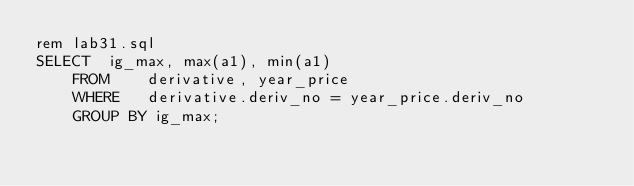<code> <loc_0><loc_0><loc_500><loc_500><_SQL_>rem lab31.sql
SELECT  ig_max, max(a1), min(a1)
	FROM	derivative, year_price
	WHERE 	derivative.deriv_no = year_price.deriv_no
	GROUP BY ig_max;
</code> 